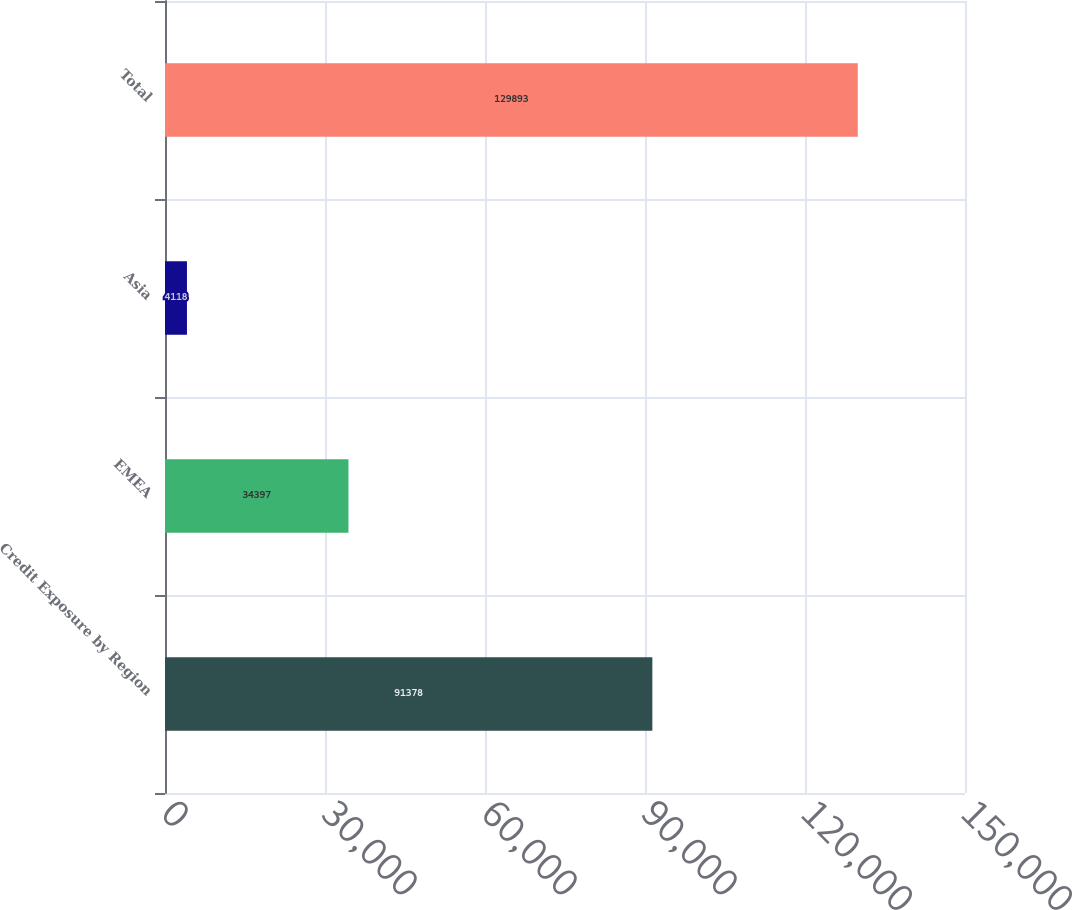<chart> <loc_0><loc_0><loc_500><loc_500><bar_chart><fcel>Credit Exposure by Region<fcel>EMEA<fcel>Asia<fcel>Total<nl><fcel>91378<fcel>34397<fcel>4118<fcel>129893<nl></chart> 